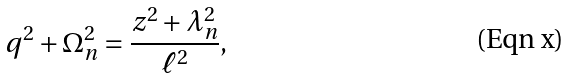Convert formula to latex. <formula><loc_0><loc_0><loc_500><loc_500>q ^ { 2 } + \Omega _ { n } ^ { 2 } = \frac { z ^ { 2 } + \lambda _ { n } ^ { 2 } } { \ell ^ { 2 } } ,</formula> 